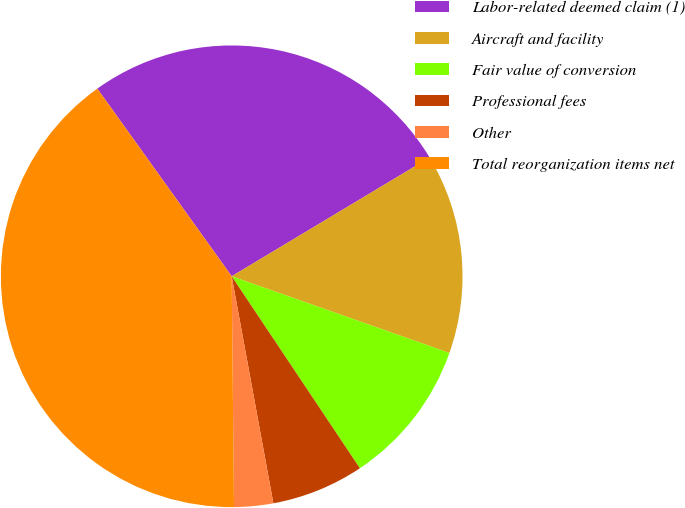<chart> <loc_0><loc_0><loc_500><loc_500><pie_chart><fcel>Labor-related deemed claim (1)<fcel>Aircraft and facility<fcel>Fair value of conversion<fcel>Professional fees<fcel>Other<fcel>Total reorganization items net<nl><fcel>26.29%<fcel>13.99%<fcel>10.24%<fcel>6.48%<fcel>2.73%<fcel>40.27%<nl></chart> 